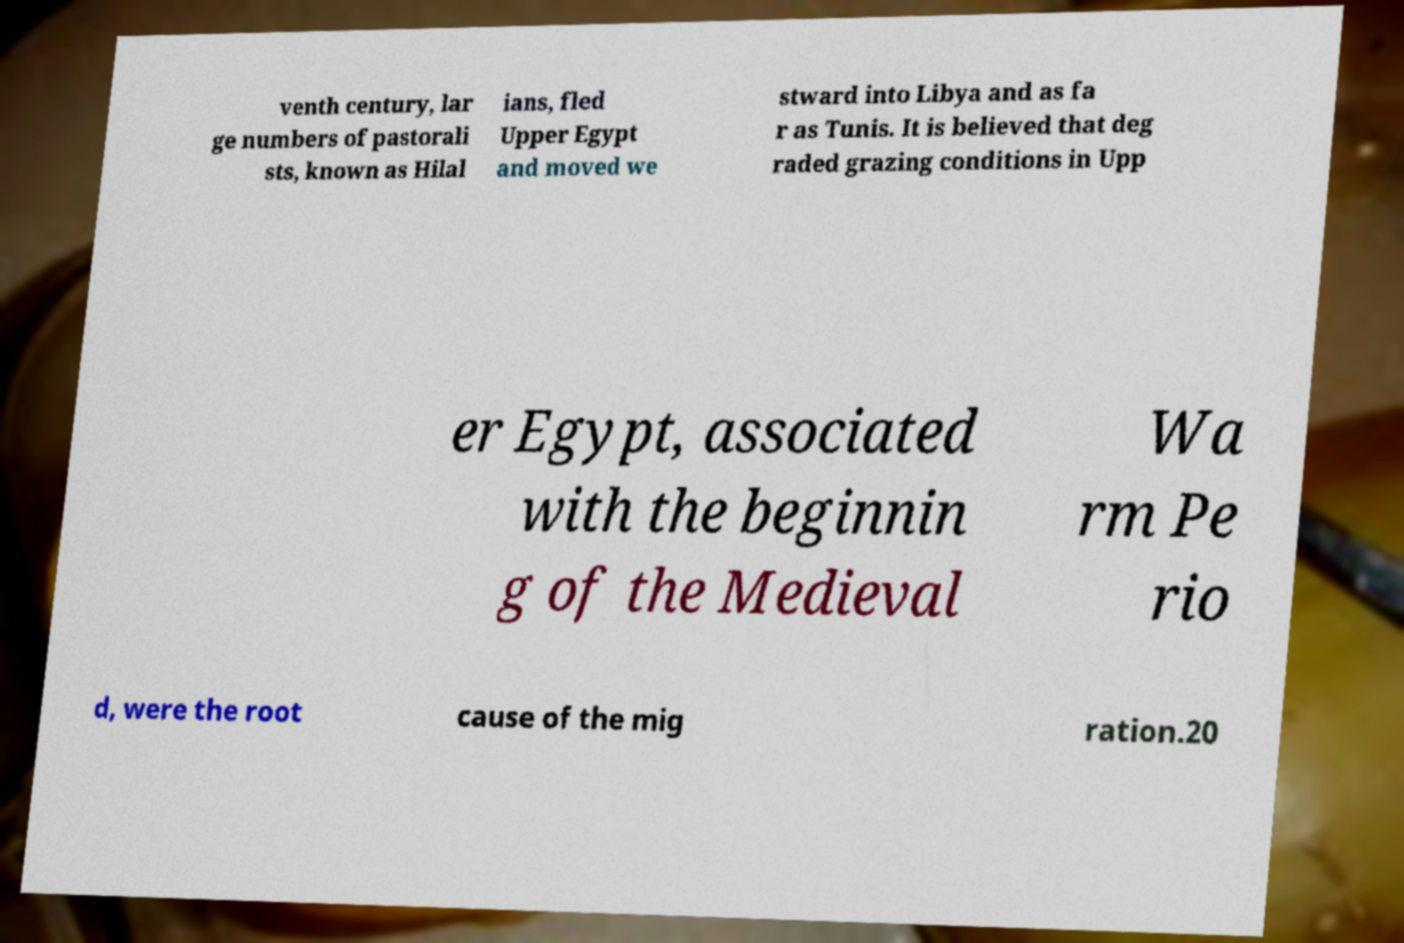Can you accurately transcribe the text from the provided image for me? venth century, lar ge numbers of pastorali sts, known as Hilal ians, fled Upper Egypt and moved we stward into Libya and as fa r as Tunis. It is believed that deg raded grazing conditions in Upp er Egypt, associated with the beginnin g of the Medieval Wa rm Pe rio d, were the root cause of the mig ration.20 